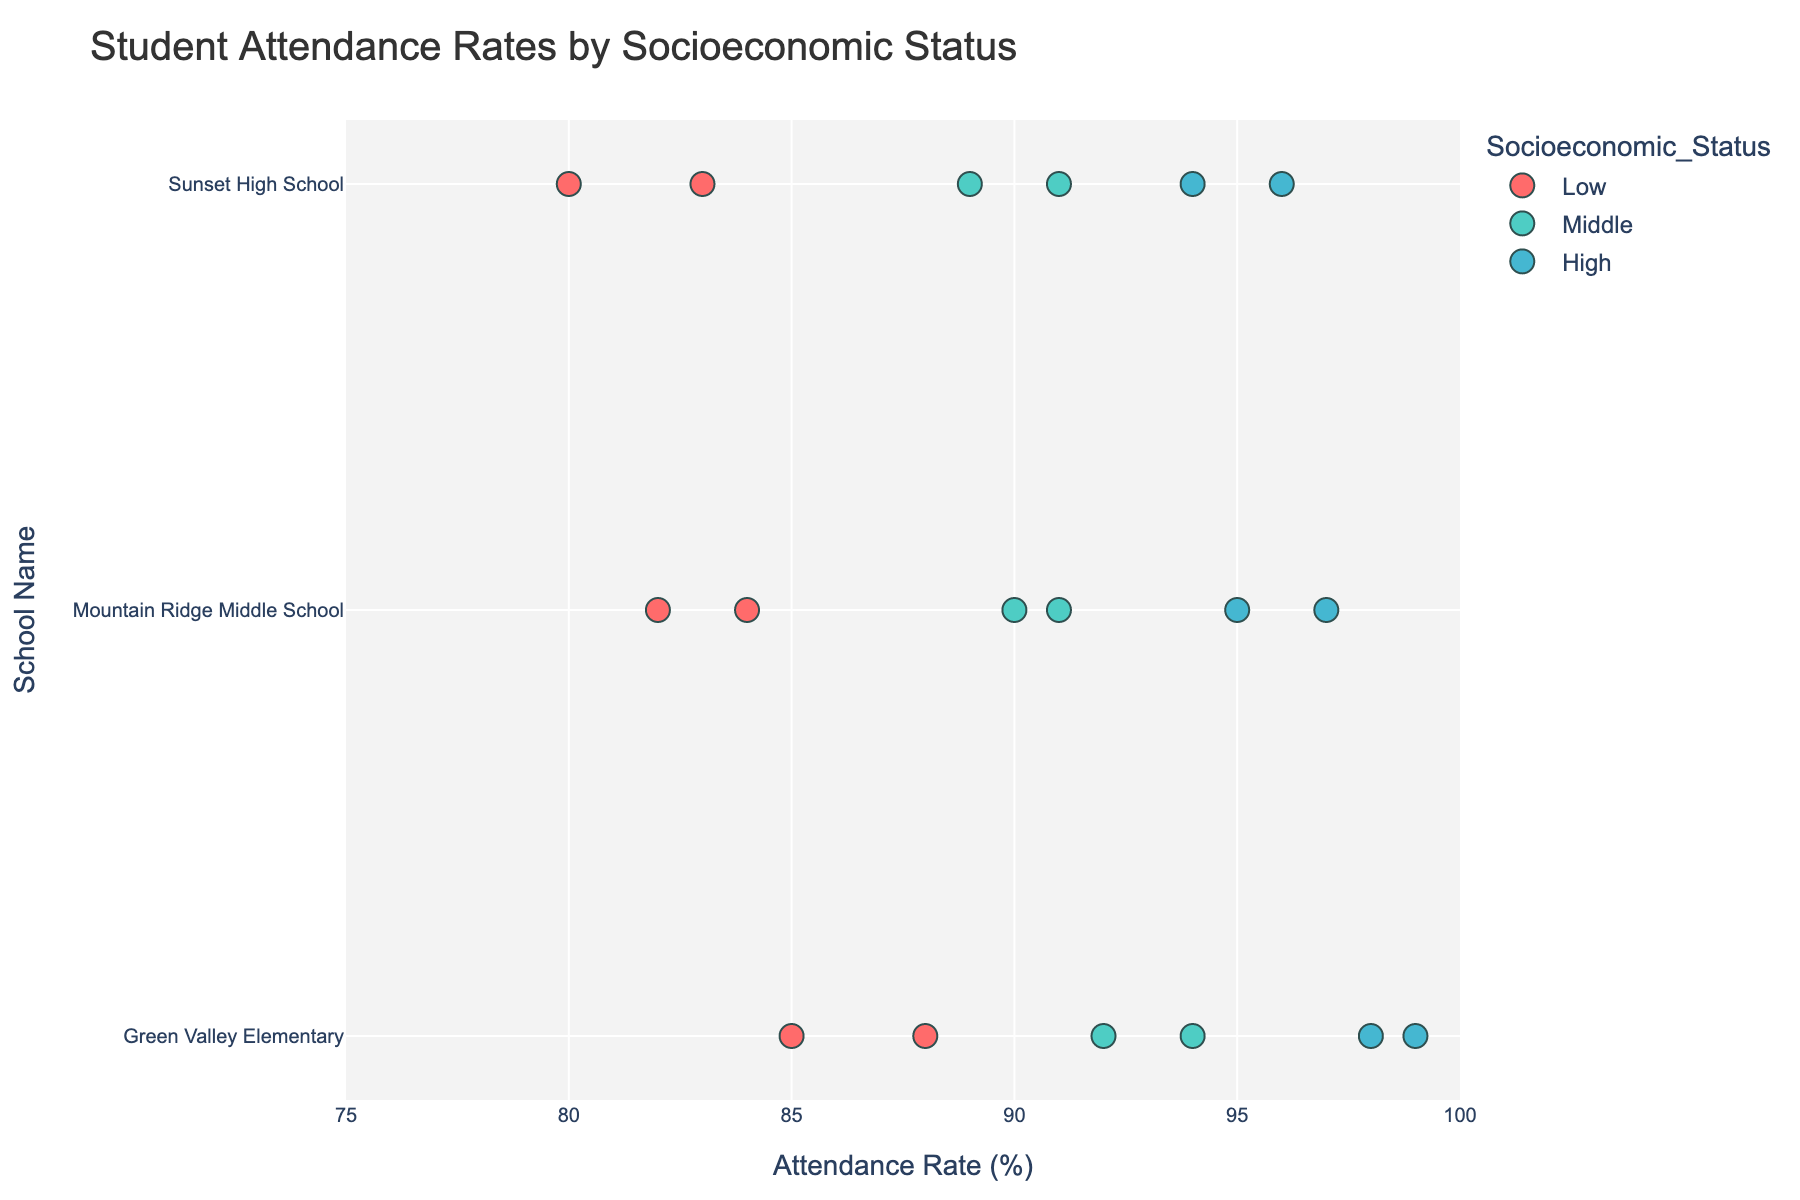What is the title of the figure? The title is usually prominently displayed at the top of the figure. In this case, it reads "Student Attendance Rates by Socioeconomic Status".
Answer: Student Attendance Rates by Socioeconomic Status Which school has the highest average attendance rate for students from middle socioeconomic status? To find this, observe the "Middle" socioeconomic colored markers and compare their locations across the schools. Green Valley Elementary has attendance rates of 92 and 94 for middle socioeconomic status, averaging to 93. Mountain Ridge Middle School's are 90 and 91, averaging to 90.5. Sunset High School's are 89 and 91, averaging to 90.
Answer: Green Valley Elementary How many low socioeconomic status students are there in total across all schools? Look for the number of markers colored according to the key for low socioeconomic status (red) across each school. Count the total data points: Green Valley Elementary (2), Mountain Ridge Middle School (2), Sunset High School (2). Sum these counts.
Answer: 6 Which socioeconomic status shows the highest attendance rate? Compare the highest attendance rate data points for each socioeconomic status color. The highest attendance rate across all students is 99, associated with the high socioeconomic status (blue point).
Answer: High What is the range of attendance rates observed in Sunset High School? Locate the data points corresponding to Sunset High School on the y-axis. The minimum attendance rate is 80, and the maximum attendance rate is 96. Calculate the difference: 96 - 80 = 16.
Answer: 16 Which school has the lowest attendance rate for high socioeconomic status students? Look for the blue markers corresponding to high socioeconomic status in each school. Identify the lowest attendance rates among these markers. The lowest among them is 94 at Sunset High School.
Answer: Sunset High School How do the attendance rates of low socioeconomic status students at Green Valley Elementary compare to those at Mountain Ridge Middle School? Compare the red markers for low socioeconomic status between these two schools. Green Valley Elementary has rates of 85 and 88, while Mountain Ridge Middle School has rates of 82 and 84. Both the attendance rates at Green Valley Elementary are higher compared to those at Mountain Ridge Middle School.
Answer: Higher at Green Valley Elementary What is the median attendance rate of all students in Sunset High School? List all the attendance rates for Sunset High School: 80, 83, 89, 91, 94, 96. To find the median, order the numbers and find the average of the middle two values (89, 91): (89 + 91) / 2 = 90.
Answer: 90 